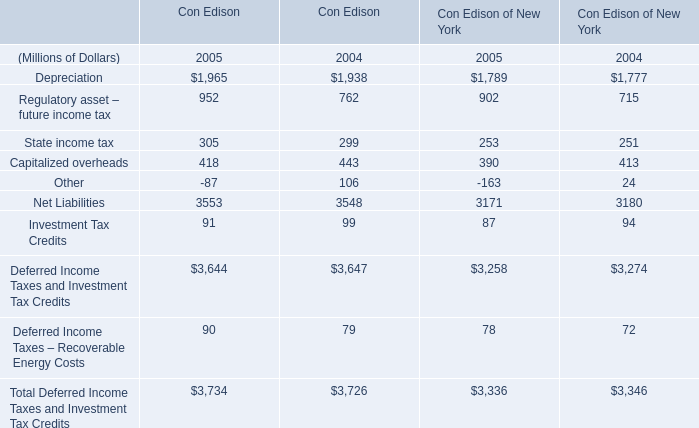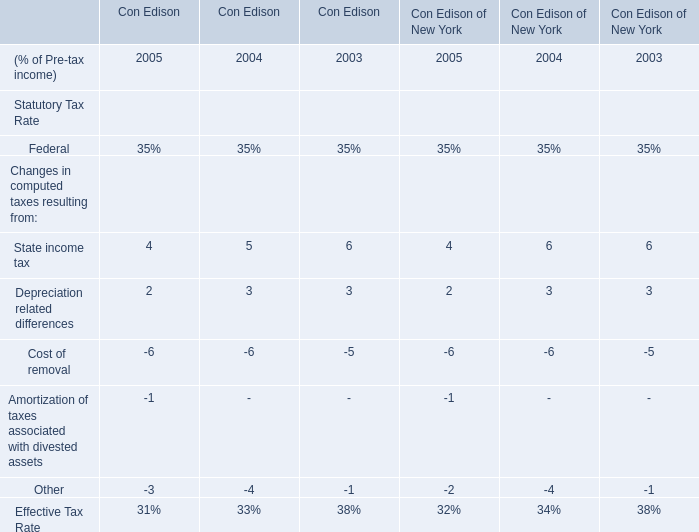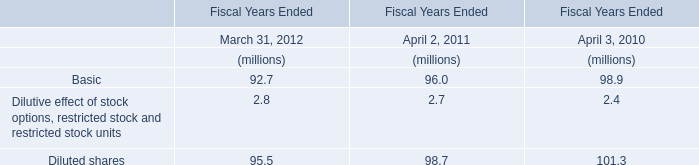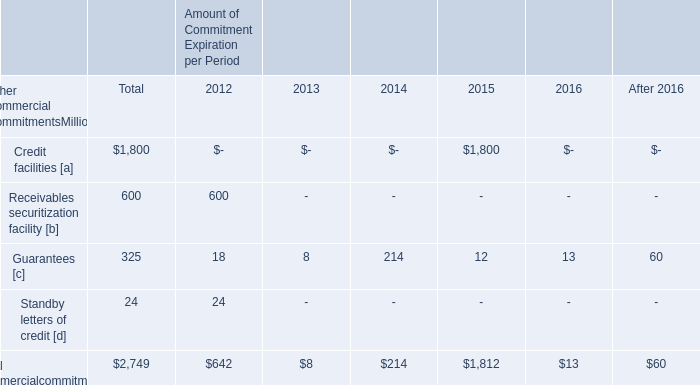What was the sum of Depreciation without those Depreciation smaller than 0 in 2005? (in million) 
Computations: (1965 + 1789)
Answer: 3754.0. 